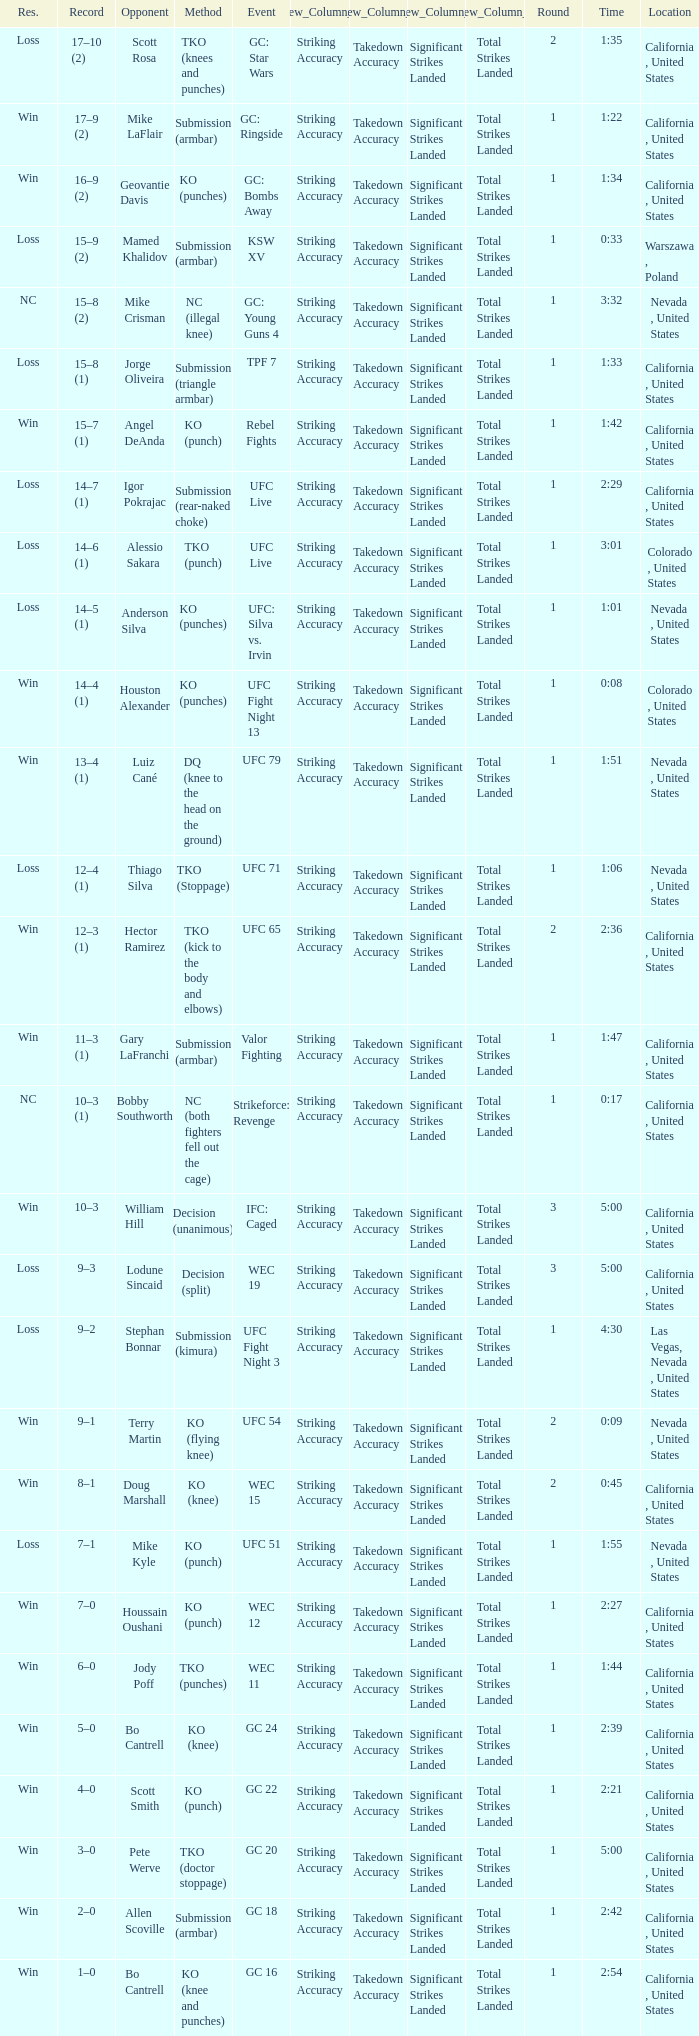What was the method when the time was 1:01? KO (punches). 